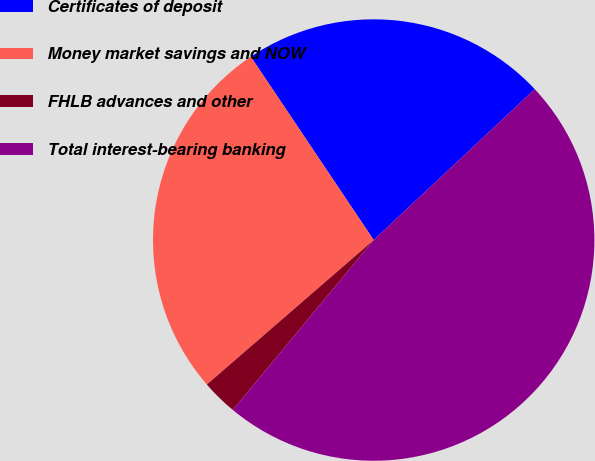<chart> <loc_0><loc_0><loc_500><loc_500><pie_chart><fcel>Certificates of deposit<fcel>Money market savings and NOW<fcel>FHLB advances and other<fcel>Total interest-bearing banking<nl><fcel>22.42%<fcel>26.96%<fcel>2.62%<fcel>48.0%<nl></chart> 